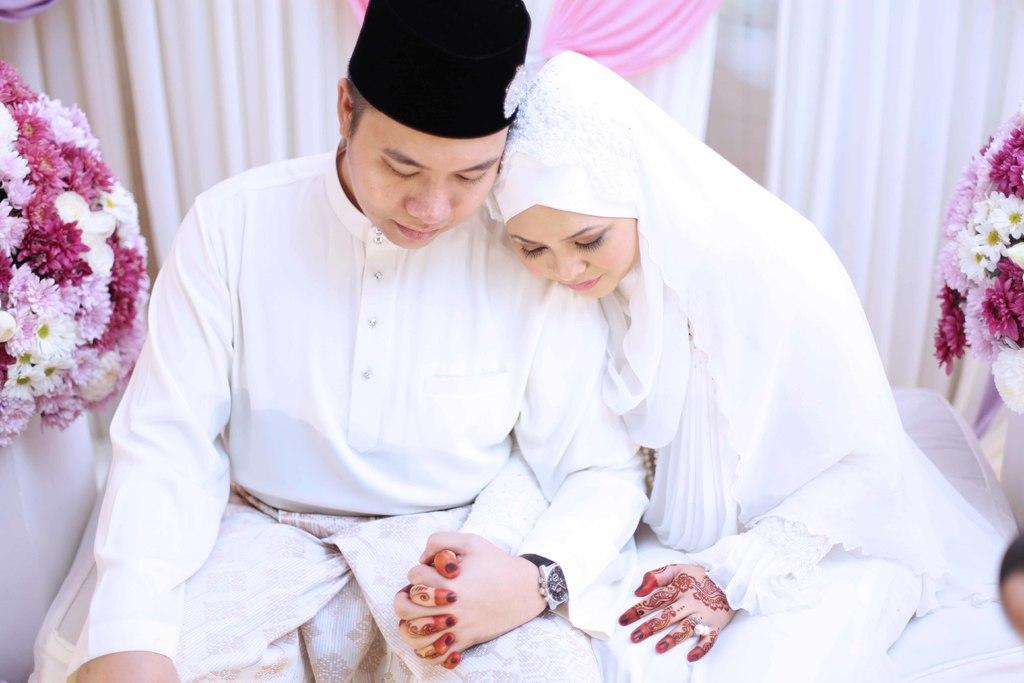How many people are in the image? There are two people in the image, a man and a woman. What are the man and woman wearing? Both the man and woman are wearing white dresses. What are the man and woman doing in the image? The man and woman are sitting. What can be seen on either side of the image? There are flowers on either side of the image. What is visible in the background of the image? There are curtains in the background of the image. What type of lumber is the man using to play the guitar in the image? There is no lumber or guitar present in the image. How does the tramp interact with the flowers on either side of the image? There is no tramp present in the image, and therefore no interaction with the flowers can be observed. 